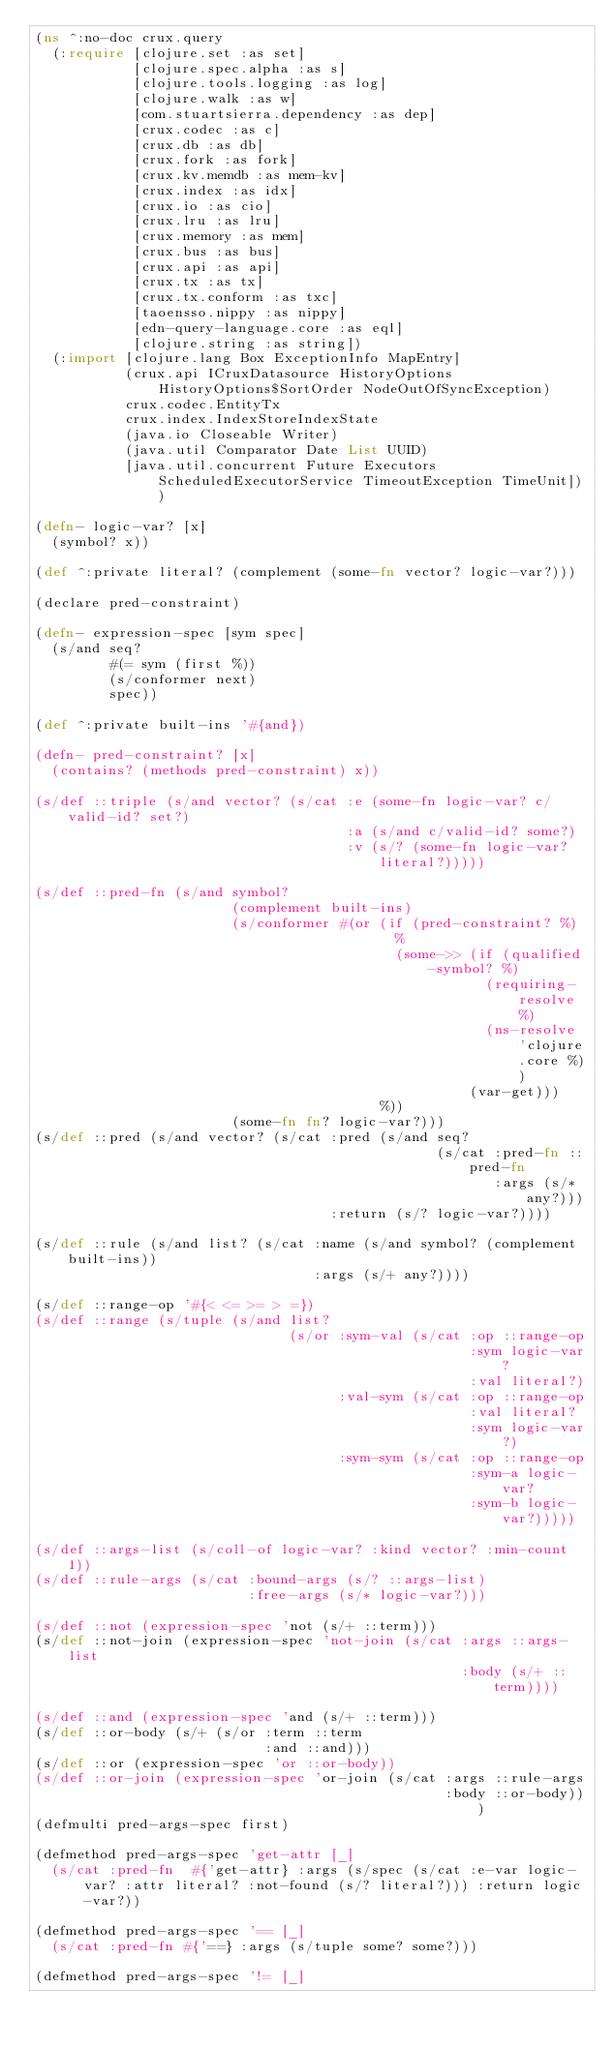Convert code to text. <code><loc_0><loc_0><loc_500><loc_500><_Clojure_>(ns ^:no-doc crux.query
  (:require [clojure.set :as set]
            [clojure.spec.alpha :as s]
            [clojure.tools.logging :as log]
            [clojure.walk :as w]
            [com.stuartsierra.dependency :as dep]
            [crux.codec :as c]
            [crux.db :as db]
            [crux.fork :as fork]
            [crux.kv.memdb :as mem-kv]
            [crux.index :as idx]
            [crux.io :as cio]
            [crux.lru :as lru]
            [crux.memory :as mem]
            [crux.bus :as bus]
            [crux.api :as api]
            [crux.tx :as tx]
            [crux.tx.conform :as txc]
            [taoensso.nippy :as nippy]
            [edn-query-language.core :as eql]
            [clojure.string :as string])
  (:import [clojure.lang Box ExceptionInfo MapEntry]
           (crux.api ICruxDatasource HistoryOptions HistoryOptions$SortOrder NodeOutOfSyncException)
           crux.codec.EntityTx
           crux.index.IndexStoreIndexState
           (java.io Closeable Writer)
           (java.util Comparator Date List UUID)
           [java.util.concurrent Future Executors ScheduledExecutorService TimeoutException TimeUnit]))

(defn- logic-var? [x]
  (symbol? x))

(def ^:private literal? (complement (some-fn vector? logic-var?)))

(declare pred-constraint)

(defn- expression-spec [sym spec]
  (s/and seq?
         #(= sym (first %))
         (s/conformer next)
         spec))

(def ^:private built-ins '#{and})

(defn- pred-constraint? [x]
  (contains? (methods pred-constraint) x))

(s/def ::triple (s/and vector? (s/cat :e (some-fn logic-var? c/valid-id? set?)
                                      :a (s/and c/valid-id? some?)
                                      :v (s/? (some-fn logic-var? literal?)))))

(s/def ::pred-fn (s/and symbol?
                        (complement built-ins)
                        (s/conformer #(or (if (pred-constraint? %)
                                            %
                                            (some->> (if (qualified-symbol? %)
                                                       (requiring-resolve %)
                                                       (ns-resolve 'clojure.core %))
                                                     (var-get)))
                                          %))
                        (some-fn fn? logic-var?)))
(s/def ::pred (s/and vector? (s/cat :pred (s/and seq?
                                                 (s/cat :pred-fn ::pred-fn
                                                        :args (s/* any?)))
                                    :return (s/? logic-var?))))

(s/def ::rule (s/and list? (s/cat :name (s/and symbol? (complement built-ins))
                                  :args (s/+ any?))))

(s/def ::range-op '#{< <= >= > =})
(s/def ::range (s/tuple (s/and list?
                               (s/or :sym-val (s/cat :op ::range-op
                                                     :sym logic-var?
                                                     :val literal?)
                                     :val-sym (s/cat :op ::range-op
                                                     :val literal?
                                                     :sym logic-var?)
                                     :sym-sym (s/cat :op ::range-op
                                                     :sym-a logic-var?
                                                     :sym-b logic-var?)))))

(s/def ::args-list (s/coll-of logic-var? :kind vector? :min-count 1))
(s/def ::rule-args (s/cat :bound-args (s/? ::args-list)
                          :free-args (s/* logic-var?)))

(s/def ::not (expression-spec 'not (s/+ ::term)))
(s/def ::not-join (expression-spec 'not-join (s/cat :args ::args-list
                                                    :body (s/+ ::term))))

(s/def ::and (expression-spec 'and (s/+ ::term)))
(s/def ::or-body (s/+ (s/or :term ::term
                            :and ::and)))
(s/def ::or (expression-spec 'or ::or-body))
(s/def ::or-join (expression-spec 'or-join (s/cat :args ::rule-args
                                                  :body ::or-body)))
(defmulti pred-args-spec first)

(defmethod pred-args-spec 'get-attr [_]
  (s/cat :pred-fn  #{'get-attr} :args (s/spec (s/cat :e-var logic-var? :attr literal? :not-found (s/? literal?))) :return logic-var?))

(defmethod pred-args-spec '== [_]
  (s/cat :pred-fn #{'==} :args (s/tuple some? some?)))

(defmethod pred-args-spec '!= [_]</code> 